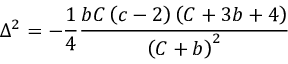Convert formula to latex. <formula><loc_0><loc_0><loc_500><loc_500>\Delta ^ { 2 } = - \frac { 1 } { 4 } \frac { b C \left ( c - 2 \right ) \left ( C + 3 b + 4 \right ) } { \left ( C + b \right ) ^ { 2 } }</formula> 